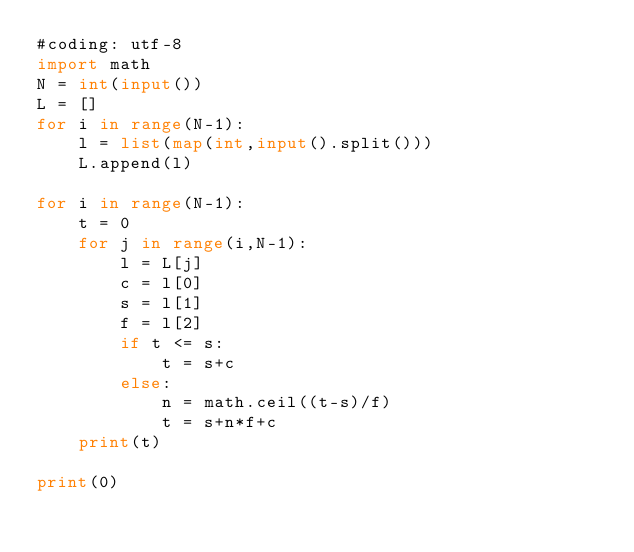<code> <loc_0><loc_0><loc_500><loc_500><_Python_>#coding: utf-8
import math
N = int(input())
L = []
for i in range(N-1):
    l = list(map(int,input().split()))
    L.append(l)

for i in range(N-1):
    t = 0
    for j in range(i,N-1):
        l = L[j]
        c = l[0]
        s = l[1]
        f = l[2]
        if t <= s:
            t = s+c
        else:
            n = math.ceil((t-s)/f)
            t = s+n*f+c
    print(t)

print(0)</code> 